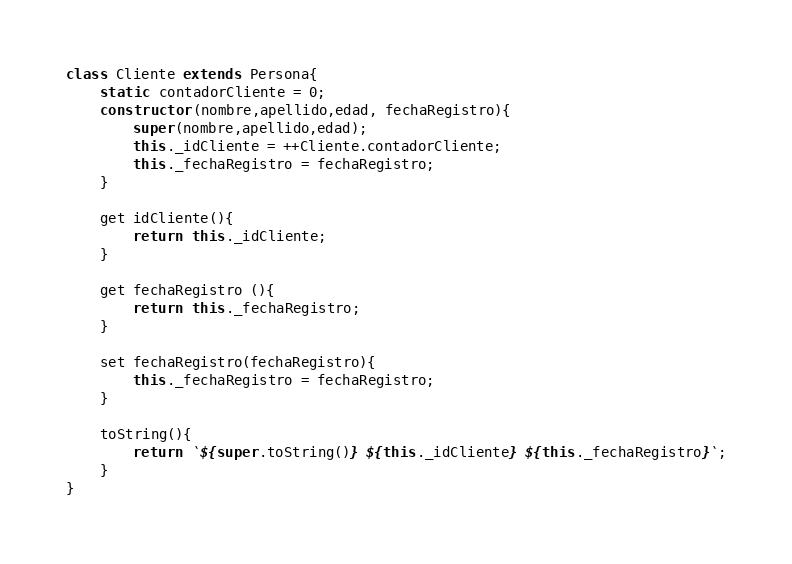<code> <loc_0><loc_0><loc_500><loc_500><_JavaScript_>class Cliente extends Persona{
    static contadorCliente = 0;
    constructor(nombre,apellido,edad, fechaRegistro){
        super(nombre,apellido,edad);
        this._idCliente = ++Cliente.contadorCliente;
        this._fechaRegistro = fechaRegistro;
    }

    get idCliente(){
        return this._idCliente;
    }

    get fechaRegistro (){
        return this._fechaRegistro;
    }

    set fechaRegistro(fechaRegistro){
        this._fechaRegistro = fechaRegistro;
    }

    toString(){
        return `${super.toString()} ${this._idCliente} ${this._fechaRegistro}`;
    }
}
</code> 